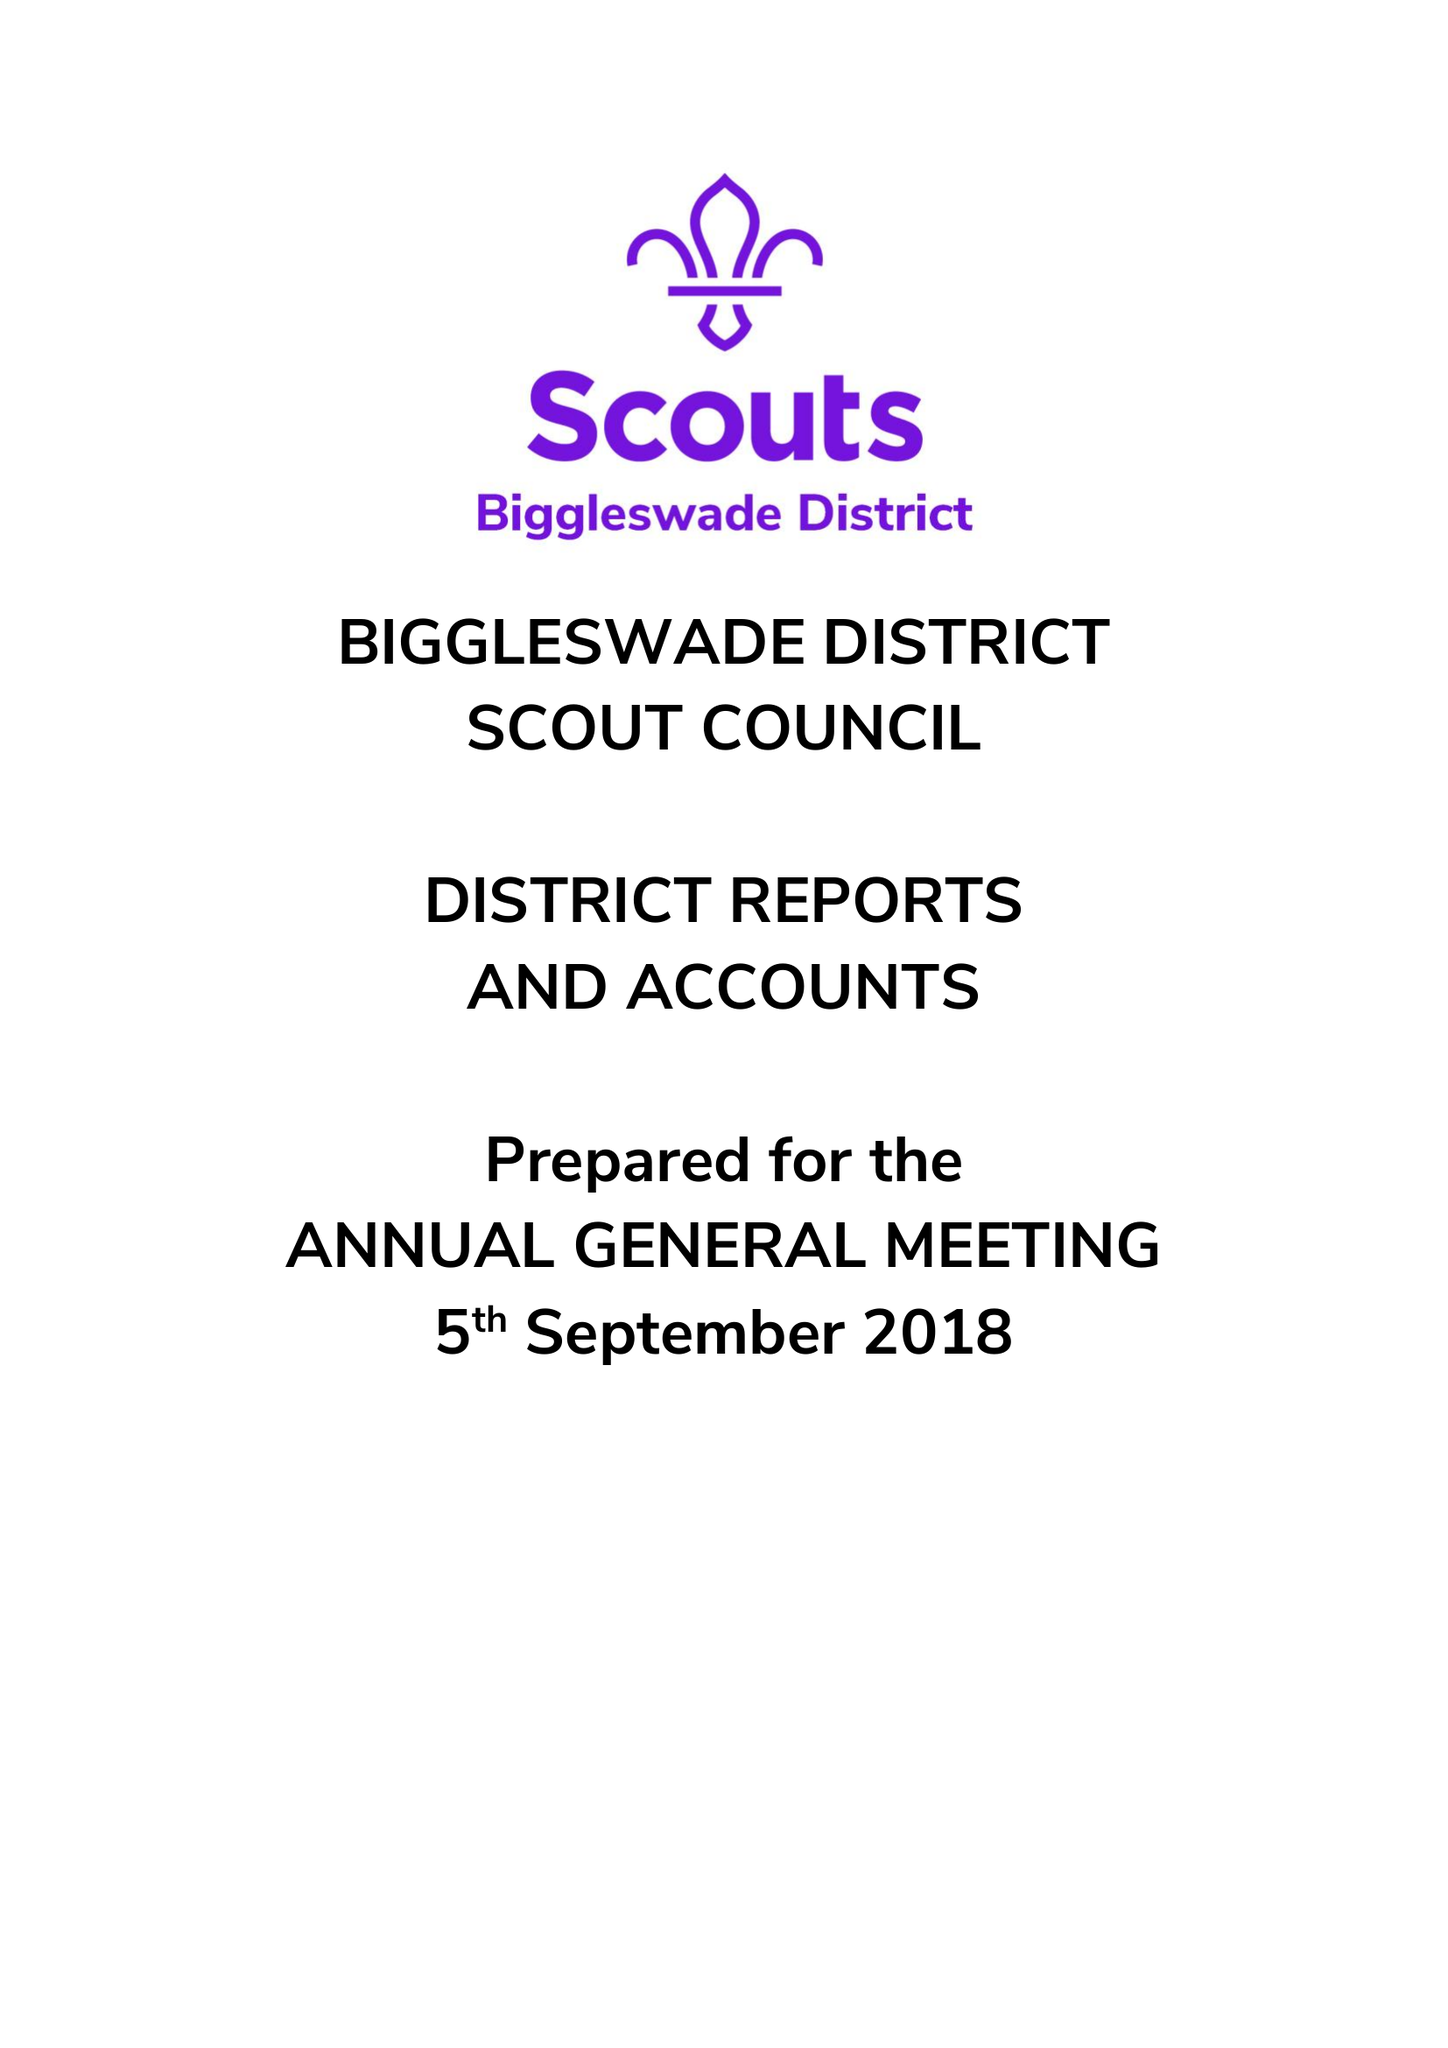What is the value for the spending_annually_in_british_pounds?
Answer the question using a single word or phrase. 42195.00 